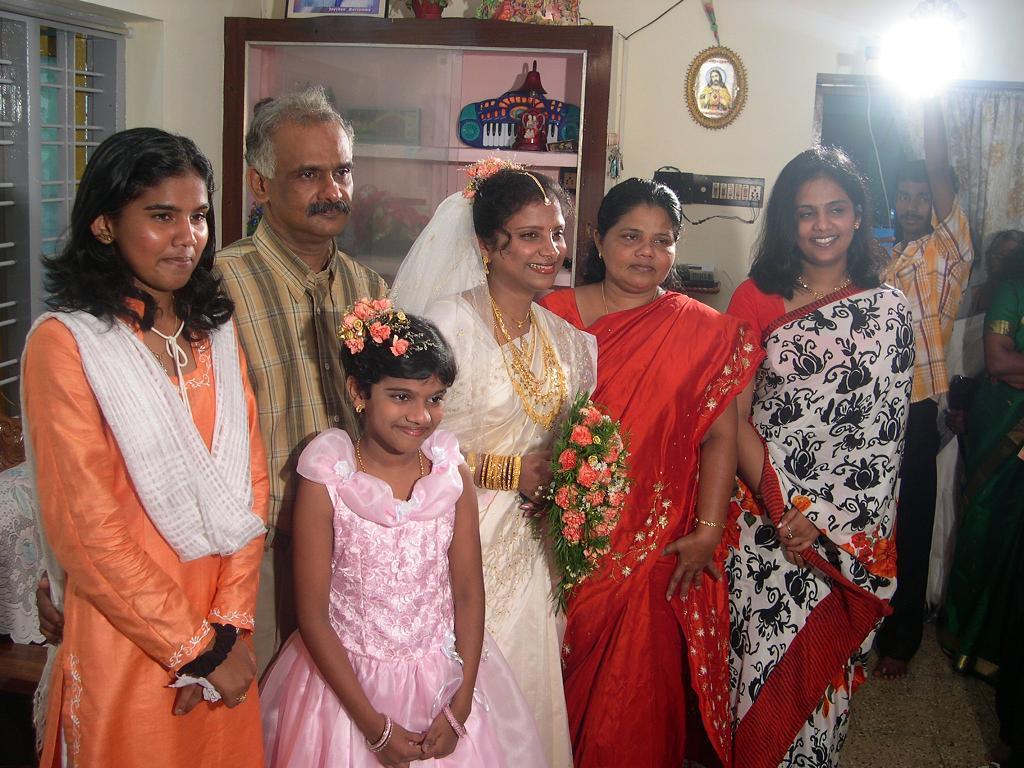Could you give a brief overview of what you see in this image? In this image we can see few people are standing on the floor. In the background we can see a window, wall, light, curtain, frames, socket, cupboard, and few objects. 